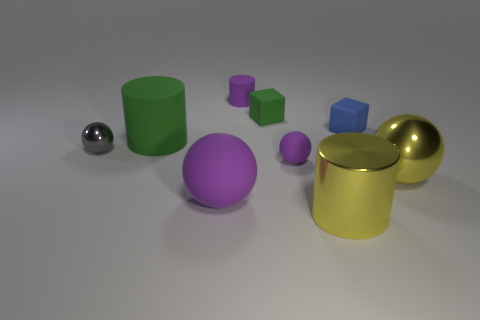Do the gray thing and the blue rubber object have the same shape?
Your response must be concise. No. What is the big cylinder that is in front of the tiny shiny ball made of?
Your response must be concise. Metal. Is the shape of the large purple matte thing the same as the green matte thing that is behind the blue object?
Offer a very short reply. No. What number of green cylinders are in front of the small sphere that is behind the small purple matte object in front of the purple cylinder?
Offer a very short reply. 0. The small matte object that is the same shape as the big purple thing is what color?
Ensure brevity in your answer.  Purple. Is there anything else that is the same shape as the tiny metal thing?
Give a very brief answer. Yes. What number of spheres are either green matte objects or shiny objects?
Offer a terse response. 2. There is a gray object; what shape is it?
Offer a terse response. Sphere. There is a small rubber sphere; are there any big shiny balls to the left of it?
Keep it short and to the point. No. Are the yellow ball and the small purple thing that is in front of the gray shiny thing made of the same material?
Ensure brevity in your answer.  No. 